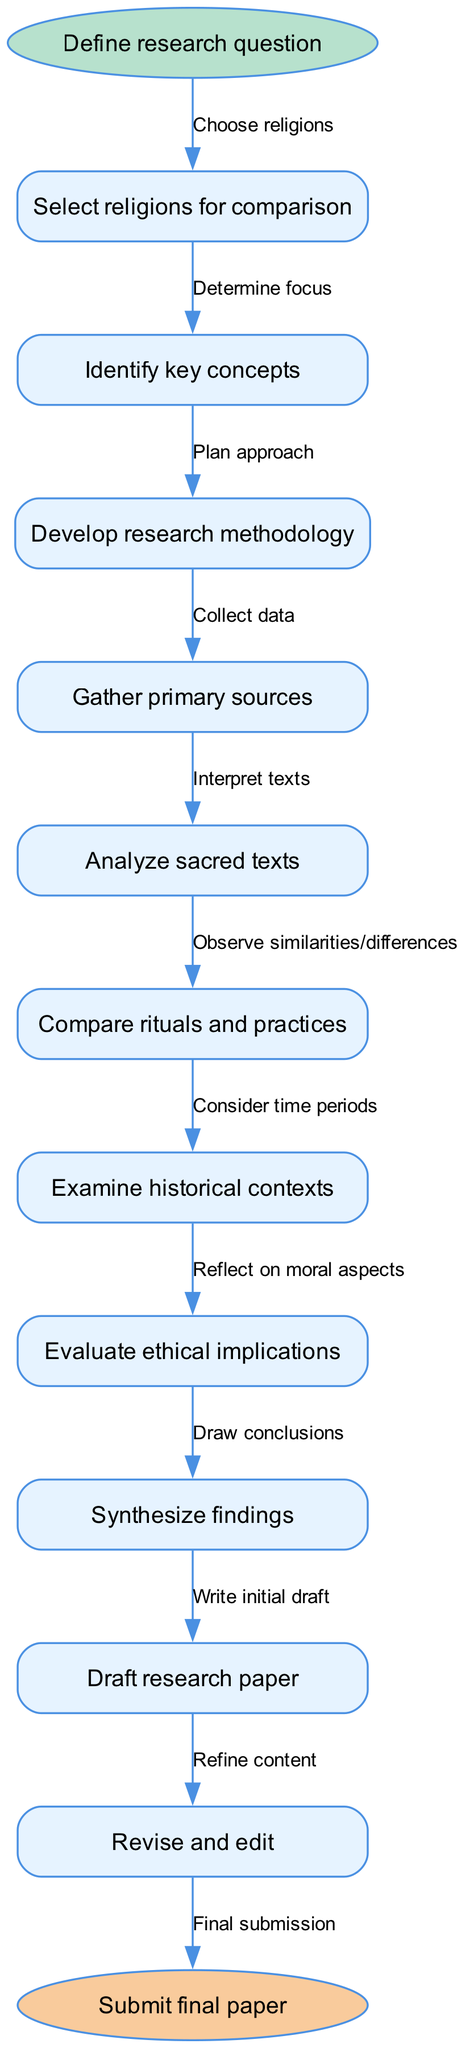What is the starting point of the flowchart? The starting point of the flowchart is indicated by the oval shape labeled "Define research question." This is the first node in the flowchart, clearly denoting where the process begins.
Answer: Define research question How many nodes are present in the diagram? The diagram consists of a total of 11 nodes including the start and end points. These include the starting point, 10 intermediate steps in the research process, and the final submission point.
Answer: 11 What is the last step before submission? The last step before submission is represented by the node labeled "Revise and edit." This step is directly linked to the final submission node, indicating that revising and editing occurs just before submission.
Answer: Revise and edit Which node follows "Analyze sacred texts"? The node that follows "Analyze sacred texts" is "Compare rituals and practices." This can be traced by following the edge that connects these two nodes in the sequential order of the flowchart.
Answer: Compare rituals and practices How does one evaluate ethical implications according to the flowchart? To evaluate ethical implications, one must reflect on moral aspects as per the edge connecting the node "Evaluate ethical implications" to "Examine historical contexts." This step indicates a consideration of ethics in relation to the broader context being analyzed.
Answer: Reflect on moral aspects What is the total number of edges leading into the end node? There is one edge leading into the end node, which connects from the last intermediate step "Revise and edit" that signifies the conclusion of the research process before final submission.
Answer: 1 What is the second node in the sequence? The second node in the sequence is "Select religions for comparison." It follows directly after the initial step of defining the research question. This node signifies a critical decision-making point in the research.
Answer: Select religions for comparison What process step involves gathering information directly from original texts? The process step involved in gathering information directly from original texts is "Gather primary sources." This node is specifically focused on the collection of data needed for the analysis.
Answer: Gather primary sources What does the node "Synthesize findings" entail just before drafting the research paper? The node "Synthesize findings" entails drawing together all the insights and results obtained through the prior research steps, which forms the basis for drafting the actual research paper. This synthesis symbolizes the integration of all comparative aspects learned.
Answer: Drawing conclusions 